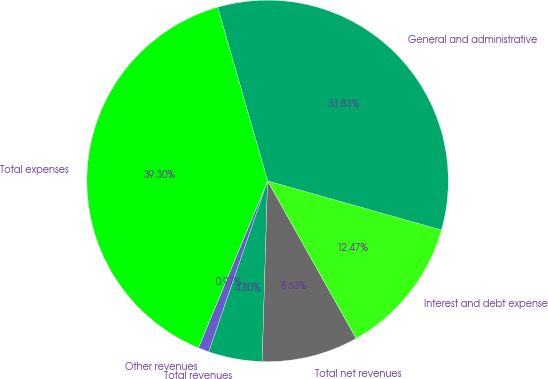<chart> <loc_0><loc_0><loc_500><loc_500><pie_chart><fcel>Other revenues<fcel>Total revenues<fcel>Total net revenues<fcel>Interest and debt expense<fcel>General and administrative<fcel>Total expenses<nl><fcel>0.97%<fcel>4.8%<fcel>8.63%<fcel>12.47%<fcel>33.83%<fcel>39.3%<nl></chart> 